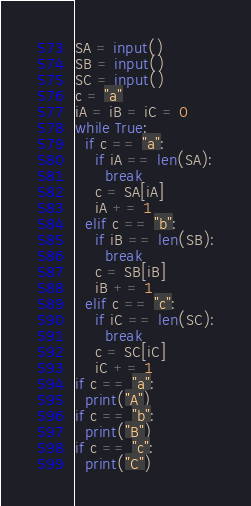<code> <loc_0><loc_0><loc_500><loc_500><_Python_>SA = input()
SB = input()
SC = input()
c = "a"
iA = iB = iC = 0
while True:
  if c == "a":
    if iA == len(SA):
      break
    c = SA[iA]
    iA += 1
  elif c == "b":
    if iB == len(SB):
      break
    c = SB[iB]
    iB += 1
  elif c == "c":
    if iC == len(SC):
      break
    c = SC[iC]
    iC += 1
if c == "a":
  print("A")
if c == "b":
  print("B")
if c == "c":
  print("C")
</code> 